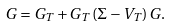<formula> <loc_0><loc_0><loc_500><loc_500>G = G _ { T } + G _ { T } \, ( \Sigma - V _ { T } ) \, G .</formula> 